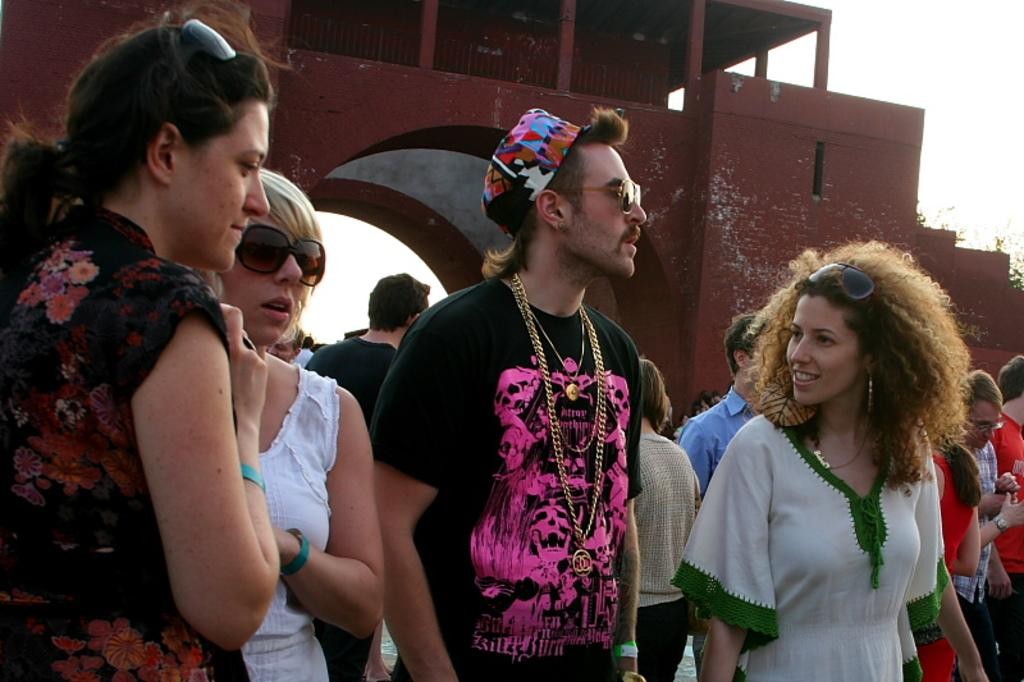What can be observed about the people in the image? There are people standing in the image. Are there any specific accessories or clothing items worn by the people? Some people are wearing glasses, and there is a person wearing chains and a cap. What is visible in the background of the image? There is a fort in the background of the image. What type of company is conducting a meeting in the image? There is no indication of a company or meeting in the image; it simply shows people standing with a fort in the background. 